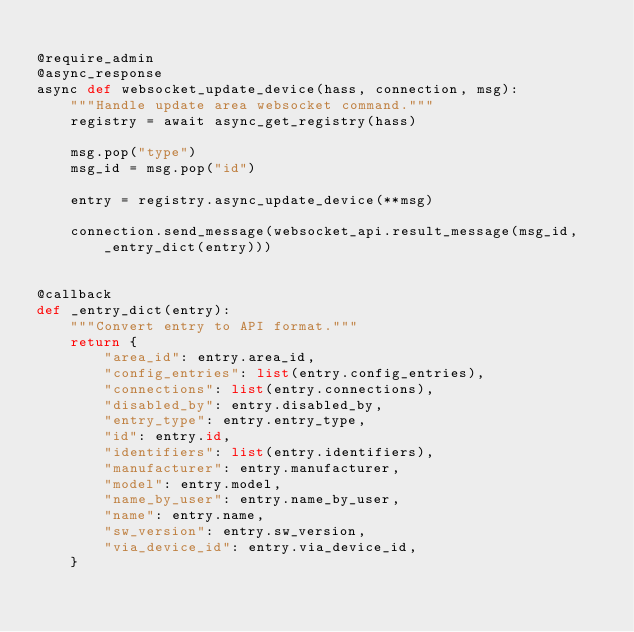Convert code to text. <code><loc_0><loc_0><loc_500><loc_500><_Python_>
@require_admin
@async_response
async def websocket_update_device(hass, connection, msg):
    """Handle update area websocket command."""
    registry = await async_get_registry(hass)

    msg.pop("type")
    msg_id = msg.pop("id")

    entry = registry.async_update_device(**msg)

    connection.send_message(websocket_api.result_message(msg_id, _entry_dict(entry)))


@callback
def _entry_dict(entry):
    """Convert entry to API format."""
    return {
        "area_id": entry.area_id,
        "config_entries": list(entry.config_entries),
        "connections": list(entry.connections),
        "disabled_by": entry.disabled_by,
        "entry_type": entry.entry_type,
        "id": entry.id,
        "identifiers": list(entry.identifiers),
        "manufacturer": entry.manufacturer,
        "model": entry.model,
        "name_by_user": entry.name_by_user,
        "name": entry.name,
        "sw_version": entry.sw_version,
        "via_device_id": entry.via_device_id,
    }
</code> 